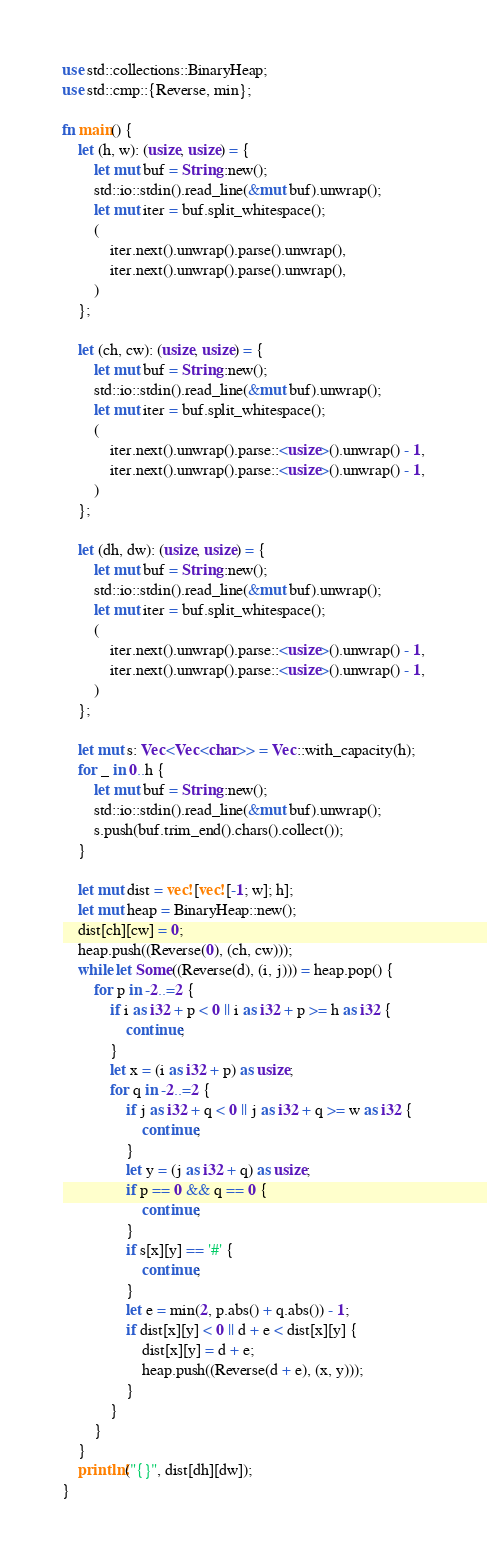<code> <loc_0><loc_0><loc_500><loc_500><_Rust_>use std::collections::BinaryHeap;
use std::cmp::{Reverse, min};

fn main() {
    let (h, w): (usize, usize) = {
        let mut buf = String::new();
        std::io::stdin().read_line(&mut buf).unwrap();
        let mut iter = buf.split_whitespace();
        (
            iter.next().unwrap().parse().unwrap(),
            iter.next().unwrap().parse().unwrap(),
        )
    };

    let (ch, cw): (usize, usize) = {
        let mut buf = String::new();
        std::io::stdin().read_line(&mut buf).unwrap();
        let mut iter = buf.split_whitespace();
        (
            iter.next().unwrap().parse::<usize>().unwrap() - 1,
            iter.next().unwrap().parse::<usize>().unwrap() - 1,
        )
    };

    let (dh, dw): (usize, usize) = {
        let mut buf = String::new();
        std::io::stdin().read_line(&mut buf).unwrap();
        let mut iter = buf.split_whitespace();
        (
            iter.next().unwrap().parse::<usize>().unwrap() - 1,
            iter.next().unwrap().parse::<usize>().unwrap() - 1,
        )
    };

    let mut s: Vec<Vec<char>> = Vec::with_capacity(h);
    for _ in 0..h {
        let mut buf = String::new();
        std::io::stdin().read_line(&mut buf).unwrap();
        s.push(buf.trim_end().chars().collect());
    }

    let mut dist = vec![vec![-1; w]; h];
    let mut heap = BinaryHeap::new();
    dist[ch][cw] = 0;
    heap.push((Reverse(0), (ch, cw)));
    while let Some((Reverse(d), (i, j))) = heap.pop() {
        for p in -2..=2 {
            if i as i32 + p < 0 || i as i32 + p >= h as i32 {
                continue;
            }
            let x = (i as i32 + p) as usize;
            for q in -2..=2 {
                if j as i32 + q < 0 || j as i32 + q >= w as i32 {
                    continue;
                }
                let y = (j as i32 + q) as usize;
                if p == 0 && q == 0 {
                    continue;
                }
                if s[x][y] == '#' {
                    continue;
                }
                let e = min(2, p.abs() + q.abs()) - 1;
                if dist[x][y] < 0 || d + e < dist[x][y] {
                    dist[x][y] = d + e;
                    heap.push((Reverse(d + e), (x, y)));
                }
            }
        }
    }
    println!("{}", dist[dh][dw]);
}</code> 